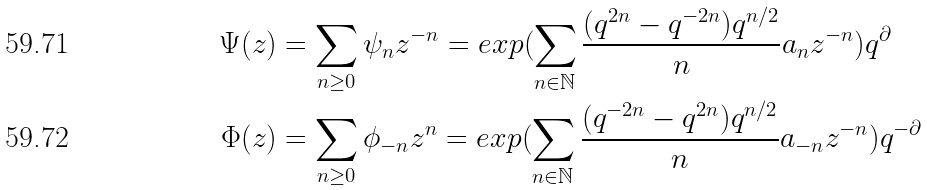Convert formula to latex. <formula><loc_0><loc_0><loc_500><loc_500>\Psi ( z ) & = \sum _ { n \geq 0 } \psi _ { n } z ^ { - n } = e x p ( \sum _ { n \in \mathbb { N } } \frac { ( q ^ { 2 n } - q ^ { - 2 n } ) q ^ { n / 2 } } n a _ { n } z ^ { - n } ) q ^ { \partial } \\ \Phi ( z ) & = \sum _ { n \geq 0 } \phi _ { - n } z ^ { n } = e x p ( \sum _ { n \in \mathbb { N } } \frac { ( q ^ { - 2 n } - q ^ { 2 n } ) q ^ { n / 2 } } n a _ { - n } z ^ { - n } ) q ^ { - \partial }</formula> 